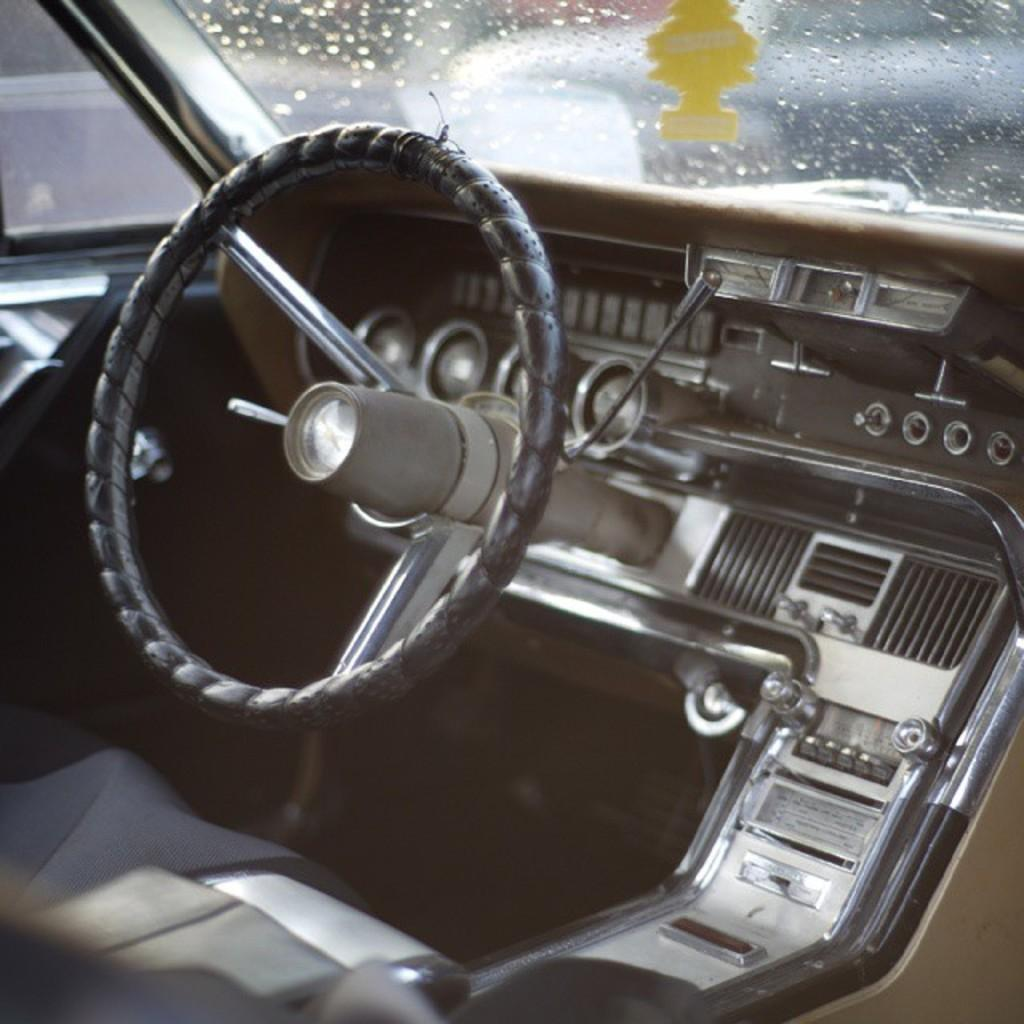What type of vehicle is shown in the image? The image shows the inner part of a vehicle, but it does not specify the type of vehicle. What can be seen in the foreground of the image? There is a steering wheel visible in the image. How would you describe the background of the image? The background of the image appears blurred. Where is the crayon placed in the image? There is no crayon present in the image. 